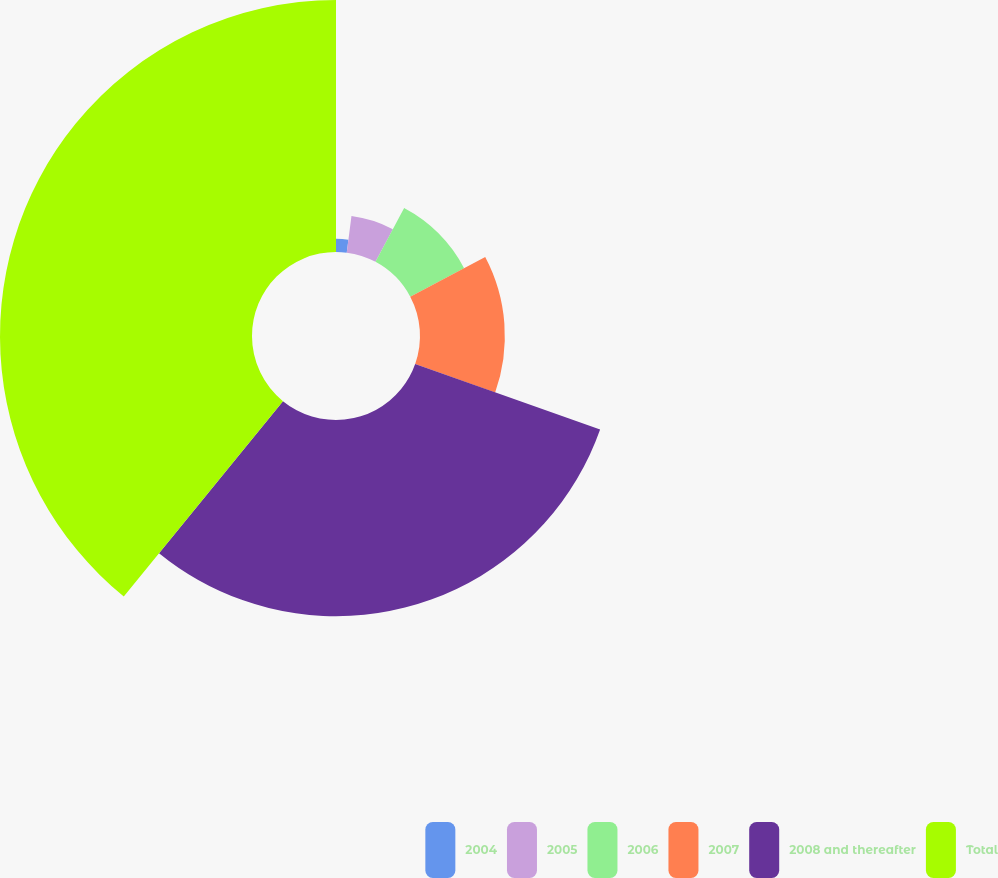<chart> <loc_0><loc_0><loc_500><loc_500><pie_chart><fcel>2004<fcel>2005<fcel>2006<fcel>2007<fcel>2008 and thereafter<fcel>Total<nl><fcel>2.04%<fcel>5.75%<fcel>9.46%<fcel>13.17%<fcel>30.46%<fcel>39.12%<nl></chart> 